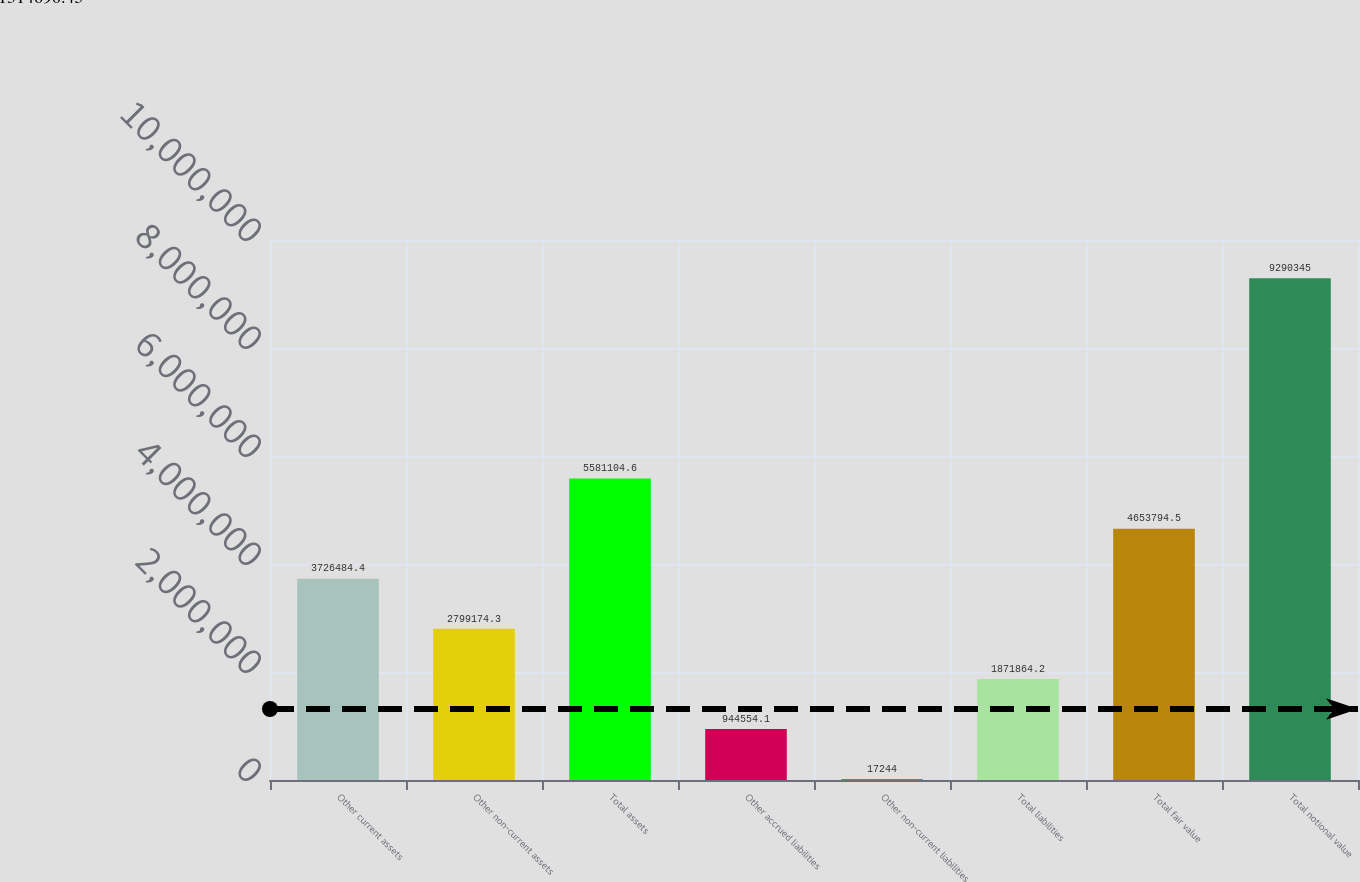<chart> <loc_0><loc_0><loc_500><loc_500><bar_chart><fcel>Other current assets<fcel>Other non-current assets<fcel>Total assets<fcel>Other accrued liabilities<fcel>Other non-current liabilities<fcel>Total liabilities<fcel>Total fair value<fcel>Total notional value<nl><fcel>3.72648e+06<fcel>2.79917e+06<fcel>5.5811e+06<fcel>944554<fcel>17244<fcel>1.87186e+06<fcel>4.65379e+06<fcel>9.29034e+06<nl></chart> 